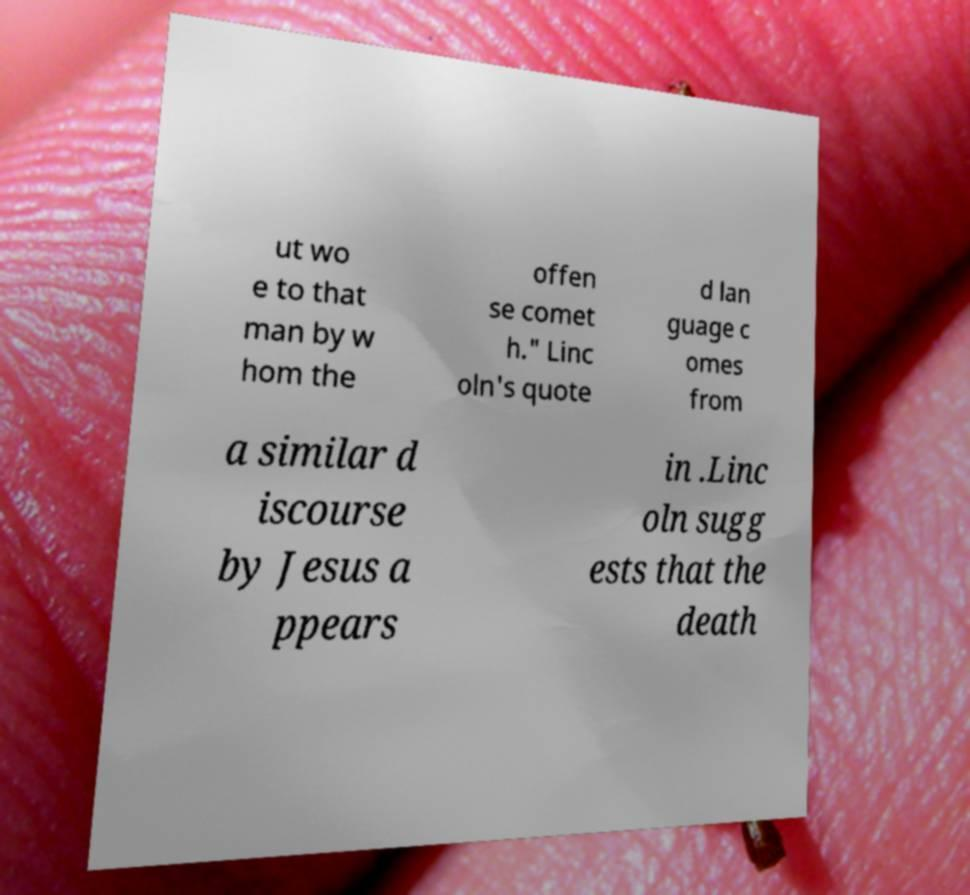For documentation purposes, I need the text within this image transcribed. Could you provide that? ut wo e to that man by w hom the offen se comet h." Linc oln's quote d lan guage c omes from a similar d iscourse by Jesus a ppears in .Linc oln sugg ests that the death 